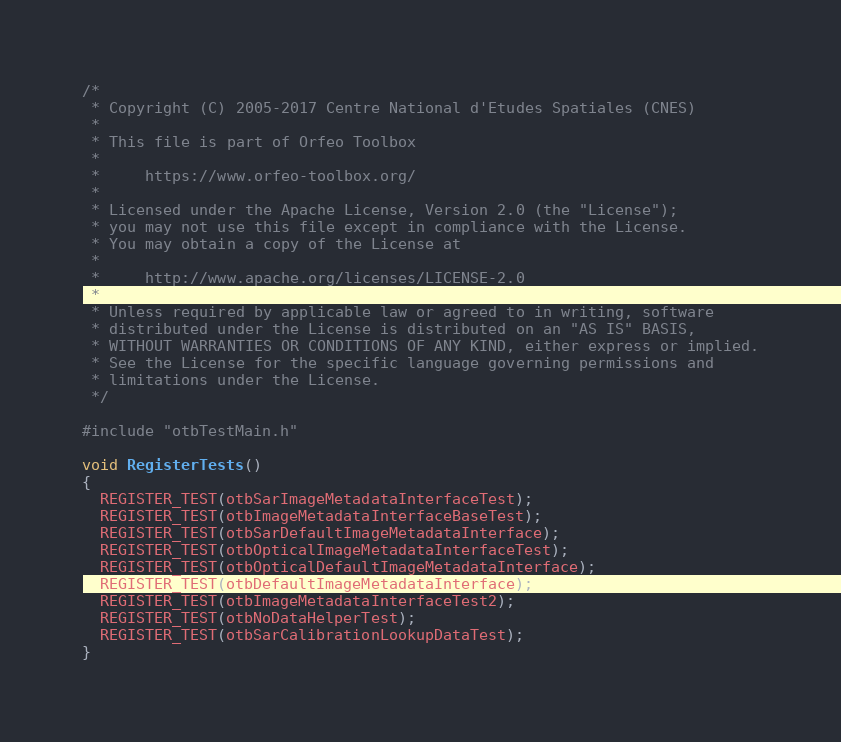<code> <loc_0><loc_0><loc_500><loc_500><_C++_>/*
 * Copyright (C) 2005-2017 Centre National d'Etudes Spatiales (CNES)
 *
 * This file is part of Orfeo Toolbox
 *
 *     https://www.orfeo-toolbox.org/
 *
 * Licensed under the Apache License, Version 2.0 (the "License");
 * you may not use this file except in compliance with the License.
 * You may obtain a copy of the License at
 *
 *     http://www.apache.org/licenses/LICENSE-2.0
 *
 * Unless required by applicable law or agreed to in writing, software
 * distributed under the License is distributed on an "AS IS" BASIS,
 * WITHOUT WARRANTIES OR CONDITIONS OF ANY KIND, either express or implied.
 * See the License for the specific language governing permissions and
 * limitations under the License.
 */

#include "otbTestMain.h"

void RegisterTests()
{
  REGISTER_TEST(otbSarImageMetadataInterfaceTest);
  REGISTER_TEST(otbImageMetadataInterfaceBaseTest);
  REGISTER_TEST(otbSarDefaultImageMetadataInterface);
  REGISTER_TEST(otbOpticalImageMetadataInterfaceTest);
  REGISTER_TEST(otbOpticalDefaultImageMetadataInterface);
  REGISTER_TEST(otbDefaultImageMetadataInterface);
  REGISTER_TEST(otbImageMetadataInterfaceTest2);
  REGISTER_TEST(otbNoDataHelperTest);
  REGISTER_TEST(otbSarCalibrationLookupDataTest);
}
</code> 